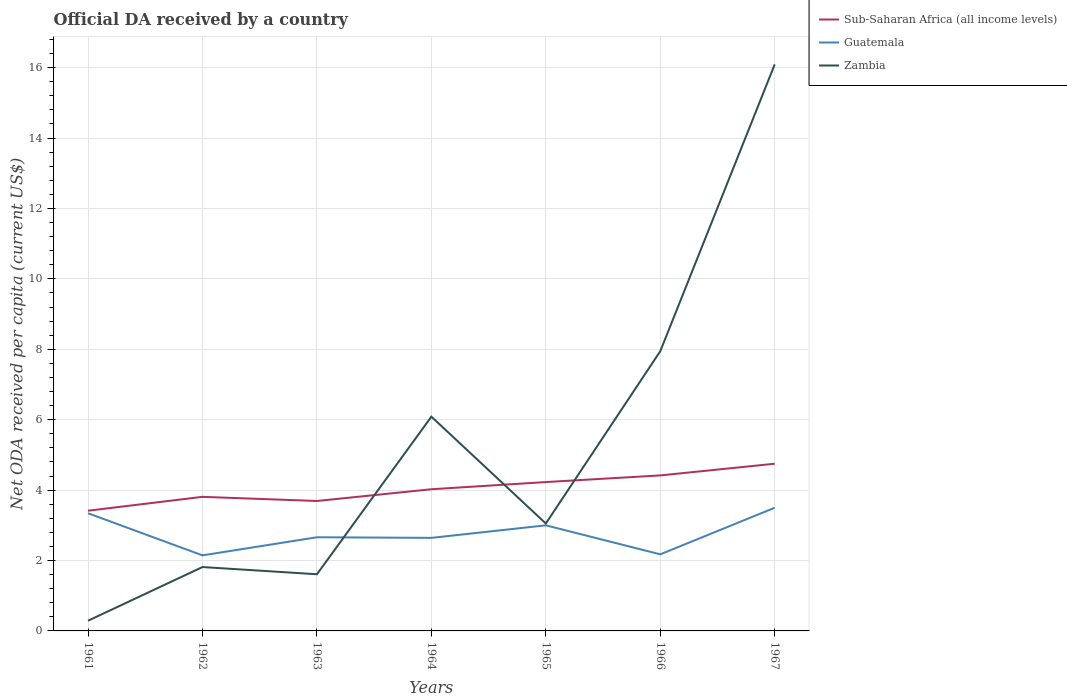Does the line corresponding to Zambia intersect with the line corresponding to Guatemala?
Keep it short and to the point. Yes. Is the number of lines equal to the number of legend labels?
Make the answer very short. Yes. Across all years, what is the maximum ODA received in in Sub-Saharan Africa (all income levels)?
Provide a succinct answer. 3.41. In which year was the ODA received in in Sub-Saharan Africa (all income levels) maximum?
Provide a short and direct response. 1961. What is the total ODA received in in Sub-Saharan Africa (all income levels) in the graph?
Provide a short and direct response. -0.39. What is the difference between the highest and the second highest ODA received in in Guatemala?
Your answer should be very brief. 1.35. What is the difference between the highest and the lowest ODA received in in Zambia?
Your response must be concise. 3. Is the ODA received in in Zambia strictly greater than the ODA received in in Guatemala over the years?
Give a very brief answer. No. How many lines are there?
Your response must be concise. 3. How many years are there in the graph?
Your response must be concise. 7. What is the difference between two consecutive major ticks on the Y-axis?
Your response must be concise. 2. Are the values on the major ticks of Y-axis written in scientific E-notation?
Provide a succinct answer. No. How many legend labels are there?
Offer a very short reply. 3. What is the title of the graph?
Your response must be concise. Official DA received by a country. Does "Northern Mariana Islands" appear as one of the legend labels in the graph?
Your answer should be compact. No. What is the label or title of the Y-axis?
Your answer should be compact. Net ODA received per capita (current US$). What is the Net ODA received per capita (current US$) in Sub-Saharan Africa (all income levels) in 1961?
Your response must be concise. 3.41. What is the Net ODA received per capita (current US$) of Guatemala in 1961?
Offer a terse response. 3.34. What is the Net ODA received per capita (current US$) of Zambia in 1961?
Keep it short and to the point. 0.29. What is the Net ODA received per capita (current US$) of Sub-Saharan Africa (all income levels) in 1962?
Keep it short and to the point. 3.81. What is the Net ODA received per capita (current US$) of Guatemala in 1962?
Your response must be concise. 2.15. What is the Net ODA received per capita (current US$) of Zambia in 1962?
Your response must be concise. 1.81. What is the Net ODA received per capita (current US$) of Sub-Saharan Africa (all income levels) in 1963?
Provide a short and direct response. 3.69. What is the Net ODA received per capita (current US$) of Guatemala in 1963?
Make the answer very short. 2.66. What is the Net ODA received per capita (current US$) of Zambia in 1963?
Provide a short and direct response. 1.61. What is the Net ODA received per capita (current US$) in Sub-Saharan Africa (all income levels) in 1964?
Provide a succinct answer. 4.02. What is the Net ODA received per capita (current US$) in Guatemala in 1964?
Offer a very short reply. 2.64. What is the Net ODA received per capita (current US$) of Zambia in 1964?
Make the answer very short. 6.09. What is the Net ODA received per capita (current US$) in Sub-Saharan Africa (all income levels) in 1965?
Your answer should be compact. 4.23. What is the Net ODA received per capita (current US$) in Guatemala in 1965?
Your response must be concise. 3. What is the Net ODA received per capita (current US$) of Zambia in 1965?
Ensure brevity in your answer.  3.05. What is the Net ODA received per capita (current US$) of Sub-Saharan Africa (all income levels) in 1966?
Ensure brevity in your answer.  4.42. What is the Net ODA received per capita (current US$) of Guatemala in 1966?
Give a very brief answer. 2.18. What is the Net ODA received per capita (current US$) in Zambia in 1966?
Your answer should be compact. 7.94. What is the Net ODA received per capita (current US$) in Sub-Saharan Africa (all income levels) in 1967?
Provide a succinct answer. 4.75. What is the Net ODA received per capita (current US$) of Guatemala in 1967?
Keep it short and to the point. 3.5. What is the Net ODA received per capita (current US$) of Zambia in 1967?
Keep it short and to the point. 16.09. Across all years, what is the maximum Net ODA received per capita (current US$) in Sub-Saharan Africa (all income levels)?
Provide a succinct answer. 4.75. Across all years, what is the maximum Net ODA received per capita (current US$) in Guatemala?
Your response must be concise. 3.5. Across all years, what is the maximum Net ODA received per capita (current US$) of Zambia?
Your answer should be very brief. 16.09. Across all years, what is the minimum Net ODA received per capita (current US$) in Sub-Saharan Africa (all income levels)?
Make the answer very short. 3.41. Across all years, what is the minimum Net ODA received per capita (current US$) of Guatemala?
Keep it short and to the point. 2.15. Across all years, what is the minimum Net ODA received per capita (current US$) in Zambia?
Your answer should be very brief. 0.29. What is the total Net ODA received per capita (current US$) of Sub-Saharan Africa (all income levels) in the graph?
Keep it short and to the point. 28.33. What is the total Net ODA received per capita (current US$) of Guatemala in the graph?
Offer a very short reply. 19.46. What is the total Net ODA received per capita (current US$) of Zambia in the graph?
Give a very brief answer. 36.89. What is the difference between the Net ODA received per capita (current US$) of Sub-Saharan Africa (all income levels) in 1961 and that in 1962?
Your response must be concise. -0.39. What is the difference between the Net ODA received per capita (current US$) in Guatemala in 1961 and that in 1962?
Your response must be concise. 1.2. What is the difference between the Net ODA received per capita (current US$) of Zambia in 1961 and that in 1962?
Offer a very short reply. -1.52. What is the difference between the Net ODA received per capita (current US$) in Sub-Saharan Africa (all income levels) in 1961 and that in 1963?
Provide a succinct answer. -0.28. What is the difference between the Net ODA received per capita (current US$) of Guatemala in 1961 and that in 1963?
Make the answer very short. 0.68. What is the difference between the Net ODA received per capita (current US$) of Zambia in 1961 and that in 1963?
Provide a short and direct response. -1.32. What is the difference between the Net ODA received per capita (current US$) of Sub-Saharan Africa (all income levels) in 1961 and that in 1964?
Give a very brief answer. -0.61. What is the difference between the Net ODA received per capita (current US$) of Guatemala in 1961 and that in 1964?
Your response must be concise. 0.7. What is the difference between the Net ODA received per capita (current US$) of Zambia in 1961 and that in 1964?
Your answer should be compact. -5.8. What is the difference between the Net ODA received per capita (current US$) in Sub-Saharan Africa (all income levels) in 1961 and that in 1965?
Keep it short and to the point. -0.81. What is the difference between the Net ODA received per capita (current US$) in Guatemala in 1961 and that in 1965?
Your answer should be compact. 0.34. What is the difference between the Net ODA received per capita (current US$) in Zambia in 1961 and that in 1965?
Provide a short and direct response. -2.76. What is the difference between the Net ODA received per capita (current US$) of Sub-Saharan Africa (all income levels) in 1961 and that in 1966?
Make the answer very short. -1. What is the difference between the Net ODA received per capita (current US$) in Guatemala in 1961 and that in 1966?
Offer a very short reply. 1.17. What is the difference between the Net ODA received per capita (current US$) in Zambia in 1961 and that in 1966?
Your answer should be very brief. -7.66. What is the difference between the Net ODA received per capita (current US$) of Sub-Saharan Africa (all income levels) in 1961 and that in 1967?
Offer a very short reply. -1.33. What is the difference between the Net ODA received per capita (current US$) in Guatemala in 1961 and that in 1967?
Offer a terse response. -0.16. What is the difference between the Net ODA received per capita (current US$) in Zambia in 1961 and that in 1967?
Your answer should be very brief. -15.8. What is the difference between the Net ODA received per capita (current US$) in Sub-Saharan Africa (all income levels) in 1962 and that in 1963?
Offer a terse response. 0.12. What is the difference between the Net ODA received per capita (current US$) in Guatemala in 1962 and that in 1963?
Your answer should be compact. -0.51. What is the difference between the Net ODA received per capita (current US$) in Zambia in 1962 and that in 1963?
Give a very brief answer. 0.21. What is the difference between the Net ODA received per capita (current US$) of Sub-Saharan Africa (all income levels) in 1962 and that in 1964?
Keep it short and to the point. -0.22. What is the difference between the Net ODA received per capita (current US$) in Guatemala in 1962 and that in 1964?
Your answer should be compact. -0.5. What is the difference between the Net ODA received per capita (current US$) in Zambia in 1962 and that in 1964?
Make the answer very short. -4.27. What is the difference between the Net ODA received per capita (current US$) in Sub-Saharan Africa (all income levels) in 1962 and that in 1965?
Give a very brief answer. -0.42. What is the difference between the Net ODA received per capita (current US$) in Guatemala in 1962 and that in 1965?
Give a very brief answer. -0.85. What is the difference between the Net ODA received per capita (current US$) in Zambia in 1962 and that in 1965?
Offer a very short reply. -1.24. What is the difference between the Net ODA received per capita (current US$) of Sub-Saharan Africa (all income levels) in 1962 and that in 1966?
Provide a short and direct response. -0.61. What is the difference between the Net ODA received per capita (current US$) in Guatemala in 1962 and that in 1966?
Give a very brief answer. -0.03. What is the difference between the Net ODA received per capita (current US$) of Zambia in 1962 and that in 1966?
Make the answer very short. -6.13. What is the difference between the Net ODA received per capita (current US$) of Sub-Saharan Africa (all income levels) in 1962 and that in 1967?
Provide a short and direct response. -0.94. What is the difference between the Net ODA received per capita (current US$) of Guatemala in 1962 and that in 1967?
Give a very brief answer. -1.35. What is the difference between the Net ODA received per capita (current US$) in Zambia in 1962 and that in 1967?
Give a very brief answer. -14.28. What is the difference between the Net ODA received per capita (current US$) of Sub-Saharan Africa (all income levels) in 1963 and that in 1964?
Offer a very short reply. -0.33. What is the difference between the Net ODA received per capita (current US$) of Guatemala in 1963 and that in 1964?
Ensure brevity in your answer.  0.02. What is the difference between the Net ODA received per capita (current US$) of Zambia in 1963 and that in 1964?
Offer a very short reply. -4.48. What is the difference between the Net ODA received per capita (current US$) in Sub-Saharan Africa (all income levels) in 1963 and that in 1965?
Your answer should be compact. -0.54. What is the difference between the Net ODA received per capita (current US$) in Guatemala in 1963 and that in 1965?
Offer a terse response. -0.34. What is the difference between the Net ODA received per capita (current US$) of Zambia in 1963 and that in 1965?
Give a very brief answer. -1.44. What is the difference between the Net ODA received per capita (current US$) of Sub-Saharan Africa (all income levels) in 1963 and that in 1966?
Provide a succinct answer. -0.73. What is the difference between the Net ODA received per capita (current US$) of Guatemala in 1963 and that in 1966?
Ensure brevity in your answer.  0.48. What is the difference between the Net ODA received per capita (current US$) of Zambia in 1963 and that in 1966?
Give a very brief answer. -6.34. What is the difference between the Net ODA received per capita (current US$) of Sub-Saharan Africa (all income levels) in 1963 and that in 1967?
Give a very brief answer. -1.06. What is the difference between the Net ODA received per capita (current US$) of Guatemala in 1963 and that in 1967?
Make the answer very short. -0.84. What is the difference between the Net ODA received per capita (current US$) of Zambia in 1963 and that in 1967?
Offer a very short reply. -14.48. What is the difference between the Net ODA received per capita (current US$) in Sub-Saharan Africa (all income levels) in 1964 and that in 1965?
Your answer should be compact. -0.2. What is the difference between the Net ODA received per capita (current US$) in Guatemala in 1964 and that in 1965?
Make the answer very short. -0.36. What is the difference between the Net ODA received per capita (current US$) of Zambia in 1964 and that in 1965?
Keep it short and to the point. 3.03. What is the difference between the Net ODA received per capita (current US$) of Sub-Saharan Africa (all income levels) in 1964 and that in 1966?
Keep it short and to the point. -0.39. What is the difference between the Net ODA received per capita (current US$) of Guatemala in 1964 and that in 1966?
Make the answer very short. 0.47. What is the difference between the Net ODA received per capita (current US$) in Zambia in 1964 and that in 1966?
Ensure brevity in your answer.  -1.86. What is the difference between the Net ODA received per capita (current US$) in Sub-Saharan Africa (all income levels) in 1964 and that in 1967?
Your answer should be very brief. -0.72. What is the difference between the Net ODA received per capita (current US$) of Guatemala in 1964 and that in 1967?
Provide a short and direct response. -0.86. What is the difference between the Net ODA received per capita (current US$) in Zambia in 1964 and that in 1967?
Make the answer very short. -10.01. What is the difference between the Net ODA received per capita (current US$) in Sub-Saharan Africa (all income levels) in 1965 and that in 1966?
Give a very brief answer. -0.19. What is the difference between the Net ODA received per capita (current US$) of Guatemala in 1965 and that in 1966?
Provide a succinct answer. 0.82. What is the difference between the Net ODA received per capita (current US$) in Zambia in 1965 and that in 1966?
Offer a terse response. -4.89. What is the difference between the Net ODA received per capita (current US$) of Sub-Saharan Africa (all income levels) in 1965 and that in 1967?
Offer a very short reply. -0.52. What is the difference between the Net ODA received per capita (current US$) of Guatemala in 1965 and that in 1967?
Your answer should be compact. -0.5. What is the difference between the Net ODA received per capita (current US$) in Zambia in 1965 and that in 1967?
Your answer should be compact. -13.04. What is the difference between the Net ODA received per capita (current US$) of Sub-Saharan Africa (all income levels) in 1966 and that in 1967?
Your answer should be very brief. -0.33. What is the difference between the Net ODA received per capita (current US$) of Guatemala in 1966 and that in 1967?
Make the answer very short. -1.32. What is the difference between the Net ODA received per capita (current US$) of Zambia in 1966 and that in 1967?
Your answer should be very brief. -8.15. What is the difference between the Net ODA received per capita (current US$) of Sub-Saharan Africa (all income levels) in 1961 and the Net ODA received per capita (current US$) of Guatemala in 1962?
Give a very brief answer. 1.27. What is the difference between the Net ODA received per capita (current US$) in Sub-Saharan Africa (all income levels) in 1961 and the Net ODA received per capita (current US$) in Zambia in 1962?
Your answer should be compact. 1.6. What is the difference between the Net ODA received per capita (current US$) in Guatemala in 1961 and the Net ODA received per capita (current US$) in Zambia in 1962?
Ensure brevity in your answer.  1.53. What is the difference between the Net ODA received per capita (current US$) of Sub-Saharan Africa (all income levels) in 1961 and the Net ODA received per capita (current US$) of Guatemala in 1963?
Ensure brevity in your answer.  0.75. What is the difference between the Net ODA received per capita (current US$) of Sub-Saharan Africa (all income levels) in 1961 and the Net ODA received per capita (current US$) of Zambia in 1963?
Make the answer very short. 1.8. What is the difference between the Net ODA received per capita (current US$) of Guatemala in 1961 and the Net ODA received per capita (current US$) of Zambia in 1963?
Provide a short and direct response. 1.73. What is the difference between the Net ODA received per capita (current US$) in Sub-Saharan Africa (all income levels) in 1961 and the Net ODA received per capita (current US$) in Guatemala in 1964?
Offer a terse response. 0.77. What is the difference between the Net ODA received per capita (current US$) in Sub-Saharan Africa (all income levels) in 1961 and the Net ODA received per capita (current US$) in Zambia in 1964?
Give a very brief answer. -2.67. What is the difference between the Net ODA received per capita (current US$) in Guatemala in 1961 and the Net ODA received per capita (current US$) in Zambia in 1964?
Keep it short and to the point. -2.74. What is the difference between the Net ODA received per capita (current US$) of Sub-Saharan Africa (all income levels) in 1961 and the Net ODA received per capita (current US$) of Guatemala in 1965?
Give a very brief answer. 0.42. What is the difference between the Net ODA received per capita (current US$) in Sub-Saharan Africa (all income levels) in 1961 and the Net ODA received per capita (current US$) in Zambia in 1965?
Make the answer very short. 0.36. What is the difference between the Net ODA received per capita (current US$) of Guatemala in 1961 and the Net ODA received per capita (current US$) of Zambia in 1965?
Give a very brief answer. 0.29. What is the difference between the Net ODA received per capita (current US$) in Sub-Saharan Africa (all income levels) in 1961 and the Net ODA received per capita (current US$) in Guatemala in 1966?
Keep it short and to the point. 1.24. What is the difference between the Net ODA received per capita (current US$) of Sub-Saharan Africa (all income levels) in 1961 and the Net ODA received per capita (current US$) of Zambia in 1966?
Offer a terse response. -4.53. What is the difference between the Net ODA received per capita (current US$) of Guatemala in 1961 and the Net ODA received per capita (current US$) of Zambia in 1966?
Your answer should be very brief. -4.6. What is the difference between the Net ODA received per capita (current US$) of Sub-Saharan Africa (all income levels) in 1961 and the Net ODA received per capita (current US$) of Guatemala in 1967?
Provide a short and direct response. -0.08. What is the difference between the Net ODA received per capita (current US$) in Sub-Saharan Africa (all income levels) in 1961 and the Net ODA received per capita (current US$) in Zambia in 1967?
Give a very brief answer. -12.68. What is the difference between the Net ODA received per capita (current US$) of Guatemala in 1961 and the Net ODA received per capita (current US$) of Zambia in 1967?
Provide a succinct answer. -12.75. What is the difference between the Net ODA received per capita (current US$) of Sub-Saharan Africa (all income levels) in 1962 and the Net ODA received per capita (current US$) of Guatemala in 1963?
Keep it short and to the point. 1.15. What is the difference between the Net ODA received per capita (current US$) in Sub-Saharan Africa (all income levels) in 1962 and the Net ODA received per capita (current US$) in Zambia in 1963?
Your answer should be compact. 2.2. What is the difference between the Net ODA received per capita (current US$) in Guatemala in 1962 and the Net ODA received per capita (current US$) in Zambia in 1963?
Provide a short and direct response. 0.54. What is the difference between the Net ODA received per capita (current US$) of Sub-Saharan Africa (all income levels) in 1962 and the Net ODA received per capita (current US$) of Guatemala in 1964?
Make the answer very short. 1.17. What is the difference between the Net ODA received per capita (current US$) of Sub-Saharan Africa (all income levels) in 1962 and the Net ODA received per capita (current US$) of Zambia in 1964?
Ensure brevity in your answer.  -2.28. What is the difference between the Net ODA received per capita (current US$) of Guatemala in 1962 and the Net ODA received per capita (current US$) of Zambia in 1964?
Provide a short and direct response. -3.94. What is the difference between the Net ODA received per capita (current US$) in Sub-Saharan Africa (all income levels) in 1962 and the Net ODA received per capita (current US$) in Guatemala in 1965?
Provide a short and direct response. 0.81. What is the difference between the Net ODA received per capita (current US$) of Sub-Saharan Africa (all income levels) in 1962 and the Net ODA received per capita (current US$) of Zambia in 1965?
Provide a short and direct response. 0.76. What is the difference between the Net ODA received per capita (current US$) of Guatemala in 1962 and the Net ODA received per capita (current US$) of Zambia in 1965?
Offer a terse response. -0.9. What is the difference between the Net ODA received per capita (current US$) of Sub-Saharan Africa (all income levels) in 1962 and the Net ODA received per capita (current US$) of Guatemala in 1966?
Ensure brevity in your answer.  1.63. What is the difference between the Net ODA received per capita (current US$) of Sub-Saharan Africa (all income levels) in 1962 and the Net ODA received per capita (current US$) of Zambia in 1966?
Give a very brief answer. -4.14. What is the difference between the Net ODA received per capita (current US$) in Guatemala in 1962 and the Net ODA received per capita (current US$) in Zambia in 1966?
Your answer should be compact. -5.8. What is the difference between the Net ODA received per capita (current US$) in Sub-Saharan Africa (all income levels) in 1962 and the Net ODA received per capita (current US$) in Guatemala in 1967?
Ensure brevity in your answer.  0.31. What is the difference between the Net ODA received per capita (current US$) in Sub-Saharan Africa (all income levels) in 1962 and the Net ODA received per capita (current US$) in Zambia in 1967?
Your response must be concise. -12.28. What is the difference between the Net ODA received per capita (current US$) of Guatemala in 1962 and the Net ODA received per capita (current US$) of Zambia in 1967?
Provide a short and direct response. -13.94. What is the difference between the Net ODA received per capita (current US$) in Sub-Saharan Africa (all income levels) in 1963 and the Net ODA received per capita (current US$) in Guatemala in 1964?
Give a very brief answer. 1.05. What is the difference between the Net ODA received per capita (current US$) in Sub-Saharan Africa (all income levels) in 1963 and the Net ODA received per capita (current US$) in Zambia in 1964?
Offer a very short reply. -2.39. What is the difference between the Net ODA received per capita (current US$) in Guatemala in 1963 and the Net ODA received per capita (current US$) in Zambia in 1964?
Give a very brief answer. -3.42. What is the difference between the Net ODA received per capita (current US$) of Sub-Saharan Africa (all income levels) in 1963 and the Net ODA received per capita (current US$) of Guatemala in 1965?
Provide a succinct answer. 0.69. What is the difference between the Net ODA received per capita (current US$) in Sub-Saharan Africa (all income levels) in 1963 and the Net ODA received per capita (current US$) in Zambia in 1965?
Provide a short and direct response. 0.64. What is the difference between the Net ODA received per capita (current US$) of Guatemala in 1963 and the Net ODA received per capita (current US$) of Zambia in 1965?
Your answer should be very brief. -0.39. What is the difference between the Net ODA received per capita (current US$) in Sub-Saharan Africa (all income levels) in 1963 and the Net ODA received per capita (current US$) in Guatemala in 1966?
Offer a very short reply. 1.52. What is the difference between the Net ODA received per capita (current US$) of Sub-Saharan Africa (all income levels) in 1963 and the Net ODA received per capita (current US$) of Zambia in 1966?
Make the answer very short. -4.25. What is the difference between the Net ODA received per capita (current US$) in Guatemala in 1963 and the Net ODA received per capita (current US$) in Zambia in 1966?
Keep it short and to the point. -5.28. What is the difference between the Net ODA received per capita (current US$) in Sub-Saharan Africa (all income levels) in 1963 and the Net ODA received per capita (current US$) in Guatemala in 1967?
Offer a terse response. 0.19. What is the difference between the Net ODA received per capita (current US$) of Sub-Saharan Africa (all income levels) in 1963 and the Net ODA received per capita (current US$) of Zambia in 1967?
Provide a succinct answer. -12.4. What is the difference between the Net ODA received per capita (current US$) in Guatemala in 1963 and the Net ODA received per capita (current US$) in Zambia in 1967?
Make the answer very short. -13.43. What is the difference between the Net ODA received per capita (current US$) in Sub-Saharan Africa (all income levels) in 1964 and the Net ODA received per capita (current US$) in Guatemala in 1965?
Give a very brief answer. 1.02. What is the difference between the Net ODA received per capita (current US$) of Guatemala in 1964 and the Net ODA received per capita (current US$) of Zambia in 1965?
Offer a terse response. -0.41. What is the difference between the Net ODA received per capita (current US$) of Sub-Saharan Africa (all income levels) in 1964 and the Net ODA received per capita (current US$) of Guatemala in 1966?
Give a very brief answer. 1.85. What is the difference between the Net ODA received per capita (current US$) of Sub-Saharan Africa (all income levels) in 1964 and the Net ODA received per capita (current US$) of Zambia in 1966?
Offer a very short reply. -3.92. What is the difference between the Net ODA received per capita (current US$) in Guatemala in 1964 and the Net ODA received per capita (current US$) in Zambia in 1966?
Your answer should be very brief. -5.3. What is the difference between the Net ODA received per capita (current US$) in Sub-Saharan Africa (all income levels) in 1964 and the Net ODA received per capita (current US$) in Guatemala in 1967?
Provide a succinct answer. 0.53. What is the difference between the Net ODA received per capita (current US$) in Sub-Saharan Africa (all income levels) in 1964 and the Net ODA received per capita (current US$) in Zambia in 1967?
Keep it short and to the point. -12.07. What is the difference between the Net ODA received per capita (current US$) of Guatemala in 1964 and the Net ODA received per capita (current US$) of Zambia in 1967?
Make the answer very short. -13.45. What is the difference between the Net ODA received per capita (current US$) in Sub-Saharan Africa (all income levels) in 1965 and the Net ODA received per capita (current US$) in Guatemala in 1966?
Ensure brevity in your answer.  2.05. What is the difference between the Net ODA received per capita (current US$) of Sub-Saharan Africa (all income levels) in 1965 and the Net ODA received per capita (current US$) of Zambia in 1966?
Ensure brevity in your answer.  -3.72. What is the difference between the Net ODA received per capita (current US$) of Guatemala in 1965 and the Net ODA received per capita (current US$) of Zambia in 1966?
Your answer should be compact. -4.95. What is the difference between the Net ODA received per capita (current US$) of Sub-Saharan Africa (all income levels) in 1965 and the Net ODA received per capita (current US$) of Guatemala in 1967?
Give a very brief answer. 0.73. What is the difference between the Net ODA received per capita (current US$) of Sub-Saharan Africa (all income levels) in 1965 and the Net ODA received per capita (current US$) of Zambia in 1967?
Make the answer very short. -11.86. What is the difference between the Net ODA received per capita (current US$) of Guatemala in 1965 and the Net ODA received per capita (current US$) of Zambia in 1967?
Keep it short and to the point. -13.09. What is the difference between the Net ODA received per capita (current US$) in Sub-Saharan Africa (all income levels) in 1966 and the Net ODA received per capita (current US$) in Guatemala in 1967?
Offer a terse response. 0.92. What is the difference between the Net ODA received per capita (current US$) of Sub-Saharan Africa (all income levels) in 1966 and the Net ODA received per capita (current US$) of Zambia in 1967?
Your answer should be compact. -11.67. What is the difference between the Net ODA received per capita (current US$) of Guatemala in 1966 and the Net ODA received per capita (current US$) of Zambia in 1967?
Provide a succinct answer. -13.92. What is the average Net ODA received per capita (current US$) of Sub-Saharan Africa (all income levels) per year?
Keep it short and to the point. 4.05. What is the average Net ODA received per capita (current US$) of Guatemala per year?
Your response must be concise. 2.78. What is the average Net ODA received per capita (current US$) in Zambia per year?
Keep it short and to the point. 5.27. In the year 1961, what is the difference between the Net ODA received per capita (current US$) in Sub-Saharan Africa (all income levels) and Net ODA received per capita (current US$) in Guatemala?
Your answer should be very brief. 0.07. In the year 1961, what is the difference between the Net ODA received per capita (current US$) of Sub-Saharan Africa (all income levels) and Net ODA received per capita (current US$) of Zambia?
Your answer should be very brief. 3.12. In the year 1961, what is the difference between the Net ODA received per capita (current US$) of Guatemala and Net ODA received per capita (current US$) of Zambia?
Your answer should be compact. 3.05. In the year 1962, what is the difference between the Net ODA received per capita (current US$) of Sub-Saharan Africa (all income levels) and Net ODA received per capita (current US$) of Guatemala?
Provide a short and direct response. 1.66. In the year 1962, what is the difference between the Net ODA received per capita (current US$) of Sub-Saharan Africa (all income levels) and Net ODA received per capita (current US$) of Zambia?
Your answer should be very brief. 1.99. In the year 1962, what is the difference between the Net ODA received per capita (current US$) of Guatemala and Net ODA received per capita (current US$) of Zambia?
Offer a terse response. 0.33. In the year 1963, what is the difference between the Net ODA received per capita (current US$) in Sub-Saharan Africa (all income levels) and Net ODA received per capita (current US$) in Guatemala?
Provide a short and direct response. 1.03. In the year 1963, what is the difference between the Net ODA received per capita (current US$) in Sub-Saharan Africa (all income levels) and Net ODA received per capita (current US$) in Zambia?
Keep it short and to the point. 2.08. In the year 1963, what is the difference between the Net ODA received per capita (current US$) of Guatemala and Net ODA received per capita (current US$) of Zambia?
Your response must be concise. 1.05. In the year 1964, what is the difference between the Net ODA received per capita (current US$) of Sub-Saharan Africa (all income levels) and Net ODA received per capita (current US$) of Guatemala?
Your answer should be very brief. 1.38. In the year 1964, what is the difference between the Net ODA received per capita (current US$) in Sub-Saharan Africa (all income levels) and Net ODA received per capita (current US$) in Zambia?
Ensure brevity in your answer.  -2.06. In the year 1964, what is the difference between the Net ODA received per capita (current US$) in Guatemala and Net ODA received per capita (current US$) in Zambia?
Give a very brief answer. -3.44. In the year 1965, what is the difference between the Net ODA received per capita (current US$) in Sub-Saharan Africa (all income levels) and Net ODA received per capita (current US$) in Guatemala?
Provide a succinct answer. 1.23. In the year 1965, what is the difference between the Net ODA received per capita (current US$) of Sub-Saharan Africa (all income levels) and Net ODA received per capita (current US$) of Zambia?
Provide a succinct answer. 1.18. In the year 1965, what is the difference between the Net ODA received per capita (current US$) of Guatemala and Net ODA received per capita (current US$) of Zambia?
Ensure brevity in your answer.  -0.05. In the year 1966, what is the difference between the Net ODA received per capita (current US$) of Sub-Saharan Africa (all income levels) and Net ODA received per capita (current US$) of Guatemala?
Offer a terse response. 2.24. In the year 1966, what is the difference between the Net ODA received per capita (current US$) in Sub-Saharan Africa (all income levels) and Net ODA received per capita (current US$) in Zambia?
Offer a terse response. -3.53. In the year 1966, what is the difference between the Net ODA received per capita (current US$) of Guatemala and Net ODA received per capita (current US$) of Zambia?
Your response must be concise. -5.77. In the year 1967, what is the difference between the Net ODA received per capita (current US$) in Sub-Saharan Africa (all income levels) and Net ODA received per capita (current US$) in Guatemala?
Your answer should be compact. 1.25. In the year 1967, what is the difference between the Net ODA received per capita (current US$) in Sub-Saharan Africa (all income levels) and Net ODA received per capita (current US$) in Zambia?
Your answer should be compact. -11.34. In the year 1967, what is the difference between the Net ODA received per capita (current US$) in Guatemala and Net ODA received per capita (current US$) in Zambia?
Keep it short and to the point. -12.59. What is the ratio of the Net ODA received per capita (current US$) in Sub-Saharan Africa (all income levels) in 1961 to that in 1962?
Your answer should be very brief. 0.9. What is the ratio of the Net ODA received per capita (current US$) of Guatemala in 1961 to that in 1962?
Offer a very short reply. 1.56. What is the ratio of the Net ODA received per capita (current US$) of Zambia in 1961 to that in 1962?
Keep it short and to the point. 0.16. What is the ratio of the Net ODA received per capita (current US$) of Sub-Saharan Africa (all income levels) in 1961 to that in 1963?
Your response must be concise. 0.93. What is the ratio of the Net ODA received per capita (current US$) of Guatemala in 1961 to that in 1963?
Ensure brevity in your answer.  1.26. What is the ratio of the Net ODA received per capita (current US$) of Zambia in 1961 to that in 1963?
Ensure brevity in your answer.  0.18. What is the ratio of the Net ODA received per capita (current US$) in Sub-Saharan Africa (all income levels) in 1961 to that in 1964?
Provide a short and direct response. 0.85. What is the ratio of the Net ODA received per capita (current US$) of Guatemala in 1961 to that in 1964?
Provide a succinct answer. 1.26. What is the ratio of the Net ODA received per capita (current US$) of Zambia in 1961 to that in 1964?
Give a very brief answer. 0.05. What is the ratio of the Net ODA received per capita (current US$) in Sub-Saharan Africa (all income levels) in 1961 to that in 1965?
Give a very brief answer. 0.81. What is the ratio of the Net ODA received per capita (current US$) in Guatemala in 1961 to that in 1965?
Your answer should be very brief. 1.11. What is the ratio of the Net ODA received per capita (current US$) in Zambia in 1961 to that in 1965?
Provide a succinct answer. 0.09. What is the ratio of the Net ODA received per capita (current US$) in Sub-Saharan Africa (all income levels) in 1961 to that in 1966?
Your response must be concise. 0.77. What is the ratio of the Net ODA received per capita (current US$) in Guatemala in 1961 to that in 1966?
Make the answer very short. 1.54. What is the ratio of the Net ODA received per capita (current US$) of Zambia in 1961 to that in 1966?
Make the answer very short. 0.04. What is the ratio of the Net ODA received per capita (current US$) in Sub-Saharan Africa (all income levels) in 1961 to that in 1967?
Provide a short and direct response. 0.72. What is the ratio of the Net ODA received per capita (current US$) in Guatemala in 1961 to that in 1967?
Offer a very short reply. 0.96. What is the ratio of the Net ODA received per capita (current US$) in Zambia in 1961 to that in 1967?
Offer a terse response. 0.02. What is the ratio of the Net ODA received per capita (current US$) in Sub-Saharan Africa (all income levels) in 1962 to that in 1963?
Your answer should be compact. 1.03. What is the ratio of the Net ODA received per capita (current US$) in Guatemala in 1962 to that in 1963?
Provide a short and direct response. 0.81. What is the ratio of the Net ODA received per capita (current US$) in Zambia in 1962 to that in 1963?
Offer a very short reply. 1.13. What is the ratio of the Net ODA received per capita (current US$) of Sub-Saharan Africa (all income levels) in 1962 to that in 1964?
Keep it short and to the point. 0.95. What is the ratio of the Net ODA received per capita (current US$) in Guatemala in 1962 to that in 1964?
Your answer should be very brief. 0.81. What is the ratio of the Net ODA received per capita (current US$) in Zambia in 1962 to that in 1964?
Ensure brevity in your answer.  0.3. What is the ratio of the Net ODA received per capita (current US$) in Sub-Saharan Africa (all income levels) in 1962 to that in 1965?
Provide a succinct answer. 0.9. What is the ratio of the Net ODA received per capita (current US$) in Guatemala in 1962 to that in 1965?
Provide a short and direct response. 0.72. What is the ratio of the Net ODA received per capita (current US$) in Zambia in 1962 to that in 1965?
Provide a succinct answer. 0.59. What is the ratio of the Net ODA received per capita (current US$) of Sub-Saharan Africa (all income levels) in 1962 to that in 1966?
Offer a very short reply. 0.86. What is the ratio of the Net ODA received per capita (current US$) in Guatemala in 1962 to that in 1966?
Give a very brief answer. 0.99. What is the ratio of the Net ODA received per capita (current US$) of Zambia in 1962 to that in 1966?
Ensure brevity in your answer.  0.23. What is the ratio of the Net ODA received per capita (current US$) in Sub-Saharan Africa (all income levels) in 1962 to that in 1967?
Keep it short and to the point. 0.8. What is the ratio of the Net ODA received per capita (current US$) of Guatemala in 1962 to that in 1967?
Your response must be concise. 0.61. What is the ratio of the Net ODA received per capita (current US$) of Zambia in 1962 to that in 1967?
Offer a terse response. 0.11. What is the ratio of the Net ODA received per capita (current US$) of Sub-Saharan Africa (all income levels) in 1963 to that in 1964?
Make the answer very short. 0.92. What is the ratio of the Net ODA received per capita (current US$) in Guatemala in 1963 to that in 1964?
Provide a succinct answer. 1.01. What is the ratio of the Net ODA received per capita (current US$) of Zambia in 1963 to that in 1964?
Offer a very short reply. 0.26. What is the ratio of the Net ODA received per capita (current US$) in Sub-Saharan Africa (all income levels) in 1963 to that in 1965?
Your answer should be compact. 0.87. What is the ratio of the Net ODA received per capita (current US$) of Guatemala in 1963 to that in 1965?
Your answer should be very brief. 0.89. What is the ratio of the Net ODA received per capita (current US$) of Zambia in 1963 to that in 1965?
Provide a short and direct response. 0.53. What is the ratio of the Net ODA received per capita (current US$) of Sub-Saharan Africa (all income levels) in 1963 to that in 1966?
Ensure brevity in your answer.  0.84. What is the ratio of the Net ODA received per capita (current US$) in Guatemala in 1963 to that in 1966?
Provide a succinct answer. 1.22. What is the ratio of the Net ODA received per capita (current US$) of Zambia in 1963 to that in 1966?
Ensure brevity in your answer.  0.2. What is the ratio of the Net ODA received per capita (current US$) in Sub-Saharan Africa (all income levels) in 1963 to that in 1967?
Provide a succinct answer. 0.78. What is the ratio of the Net ODA received per capita (current US$) of Guatemala in 1963 to that in 1967?
Offer a terse response. 0.76. What is the ratio of the Net ODA received per capita (current US$) of Sub-Saharan Africa (all income levels) in 1964 to that in 1965?
Offer a very short reply. 0.95. What is the ratio of the Net ODA received per capita (current US$) in Guatemala in 1964 to that in 1965?
Ensure brevity in your answer.  0.88. What is the ratio of the Net ODA received per capita (current US$) of Zambia in 1964 to that in 1965?
Offer a very short reply. 1.99. What is the ratio of the Net ODA received per capita (current US$) in Sub-Saharan Africa (all income levels) in 1964 to that in 1966?
Make the answer very short. 0.91. What is the ratio of the Net ODA received per capita (current US$) of Guatemala in 1964 to that in 1966?
Your answer should be very brief. 1.21. What is the ratio of the Net ODA received per capita (current US$) in Zambia in 1964 to that in 1966?
Your response must be concise. 0.77. What is the ratio of the Net ODA received per capita (current US$) of Sub-Saharan Africa (all income levels) in 1964 to that in 1967?
Keep it short and to the point. 0.85. What is the ratio of the Net ODA received per capita (current US$) of Guatemala in 1964 to that in 1967?
Provide a short and direct response. 0.76. What is the ratio of the Net ODA received per capita (current US$) of Zambia in 1964 to that in 1967?
Your answer should be very brief. 0.38. What is the ratio of the Net ODA received per capita (current US$) of Sub-Saharan Africa (all income levels) in 1965 to that in 1966?
Offer a terse response. 0.96. What is the ratio of the Net ODA received per capita (current US$) of Guatemala in 1965 to that in 1966?
Your response must be concise. 1.38. What is the ratio of the Net ODA received per capita (current US$) of Zambia in 1965 to that in 1966?
Your response must be concise. 0.38. What is the ratio of the Net ODA received per capita (current US$) of Sub-Saharan Africa (all income levels) in 1965 to that in 1967?
Provide a short and direct response. 0.89. What is the ratio of the Net ODA received per capita (current US$) of Guatemala in 1965 to that in 1967?
Offer a very short reply. 0.86. What is the ratio of the Net ODA received per capita (current US$) of Zambia in 1965 to that in 1967?
Offer a terse response. 0.19. What is the ratio of the Net ODA received per capita (current US$) of Sub-Saharan Africa (all income levels) in 1966 to that in 1967?
Give a very brief answer. 0.93. What is the ratio of the Net ODA received per capita (current US$) of Guatemala in 1966 to that in 1967?
Give a very brief answer. 0.62. What is the ratio of the Net ODA received per capita (current US$) of Zambia in 1966 to that in 1967?
Provide a short and direct response. 0.49. What is the difference between the highest and the second highest Net ODA received per capita (current US$) in Sub-Saharan Africa (all income levels)?
Your answer should be compact. 0.33. What is the difference between the highest and the second highest Net ODA received per capita (current US$) in Guatemala?
Your answer should be compact. 0.16. What is the difference between the highest and the second highest Net ODA received per capita (current US$) in Zambia?
Provide a short and direct response. 8.15. What is the difference between the highest and the lowest Net ODA received per capita (current US$) of Sub-Saharan Africa (all income levels)?
Offer a very short reply. 1.33. What is the difference between the highest and the lowest Net ODA received per capita (current US$) of Guatemala?
Your answer should be very brief. 1.35. What is the difference between the highest and the lowest Net ODA received per capita (current US$) of Zambia?
Provide a short and direct response. 15.8. 